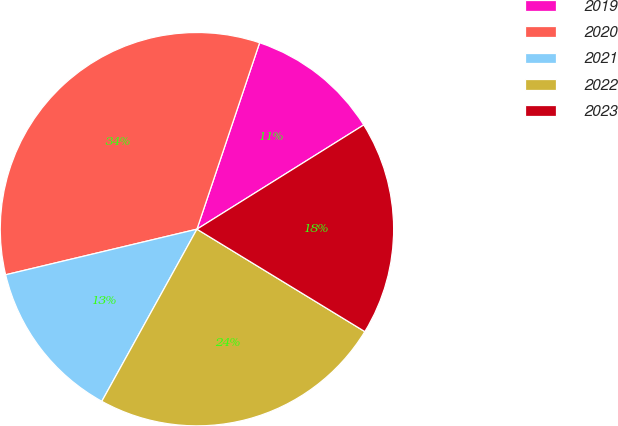<chart> <loc_0><loc_0><loc_500><loc_500><pie_chart><fcel>2019<fcel>2020<fcel>2021<fcel>2022<fcel>2023<nl><fcel>10.95%<fcel>33.89%<fcel>13.24%<fcel>24.32%<fcel>17.61%<nl></chart> 